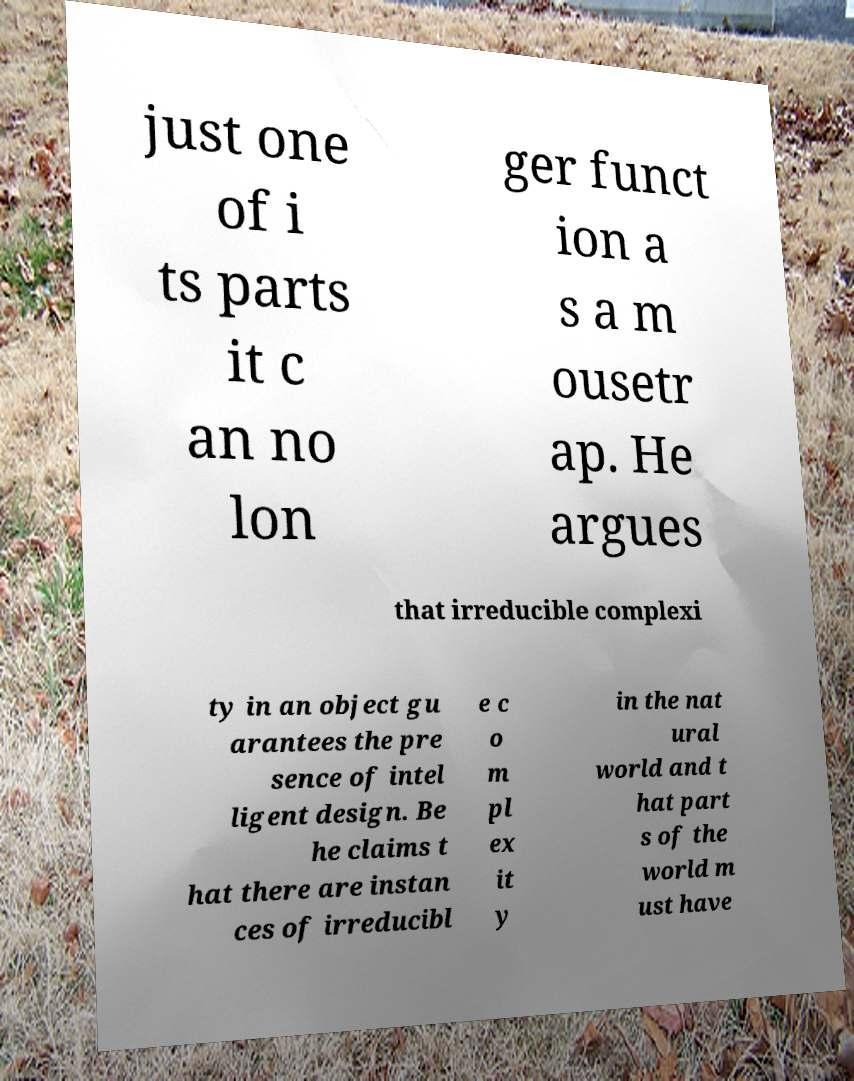Could you assist in decoding the text presented in this image and type it out clearly? just one of i ts parts it c an no lon ger funct ion a s a m ousetr ap. He argues that irreducible complexi ty in an object gu arantees the pre sence of intel ligent design. Be he claims t hat there are instan ces of irreducibl e c o m pl ex it y in the nat ural world and t hat part s of the world m ust have 